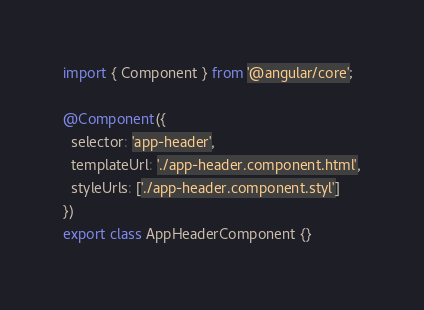Convert code to text. <code><loc_0><loc_0><loc_500><loc_500><_TypeScript_>import { Component } from '@angular/core';

@Component({
  selector: 'app-header',
  templateUrl: './app-header.component.html',
  styleUrls: ['./app-header.component.styl']
})
export class AppHeaderComponent {}
</code> 